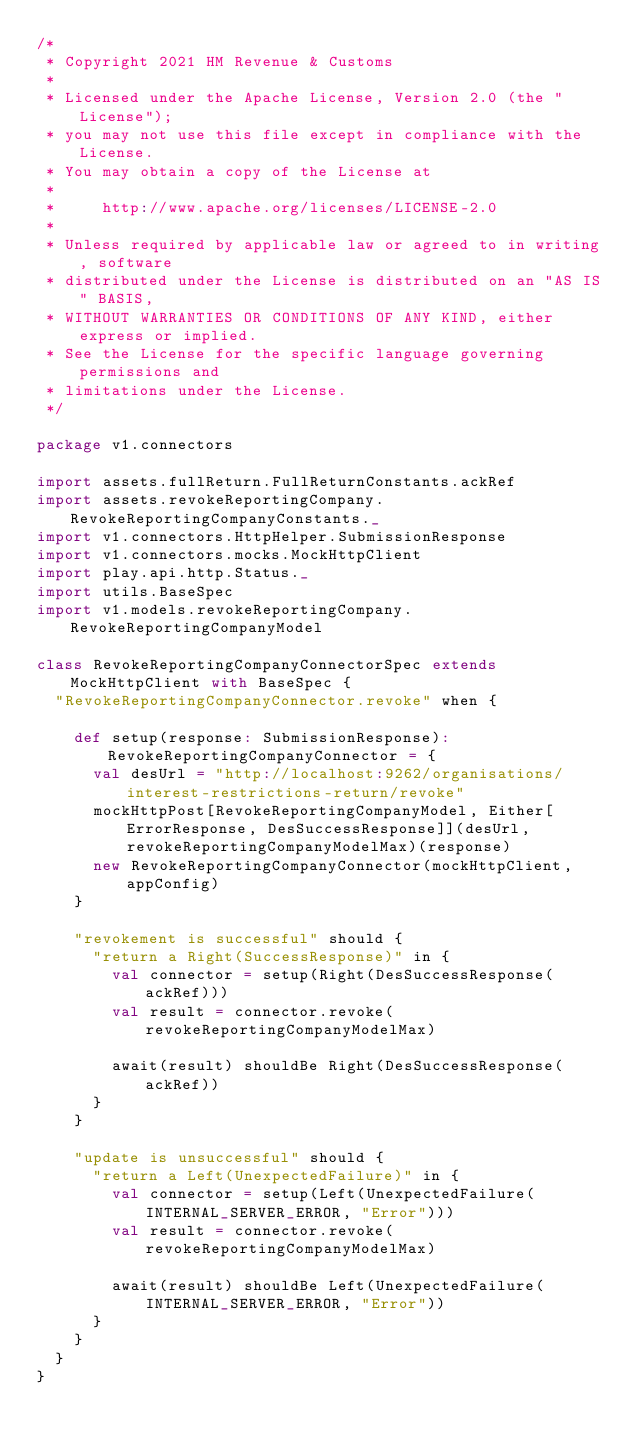Convert code to text. <code><loc_0><loc_0><loc_500><loc_500><_Scala_>/*
 * Copyright 2021 HM Revenue & Customs
 *
 * Licensed under the Apache License, Version 2.0 (the "License");
 * you may not use this file except in compliance with the License.
 * You may obtain a copy of the License at
 *
 *     http://www.apache.org/licenses/LICENSE-2.0
 *
 * Unless required by applicable law or agreed to in writing, software
 * distributed under the License is distributed on an "AS IS" BASIS,
 * WITHOUT WARRANTIES OR CONDITIONS OF ANY KIND, either express or implied.
 * See the License for the specific language governing permissions and
 * limitations under the License.
 */

package v1.connectors

import assets.fullReturn.FullReturnConstants.ackRef
import assets.revokeReportingCompany.RevokeReportingCompanyConstants._
import v1.connectors.HttpHelper.SubmissionResponse
import v1.connectors.mocks.MockHttpClient
import play.api.http.Status._
import utils.BaseSpec
import v1.models.revokeReportingCompany.RevokeReportingCompanyModel

class RevokeReportingCompanyConnectorSpec extends MockHttpClient with BaseSpec {
  "RevokeReportingCompanyConnector.revoke" when {

    def setup(response: SubmissionResponse): RevokeReportingCompanyConnector = {
      val desUrl = "http://localhost:9262/organisations/interest-restrictions-return/revoke"
      mockHttpPost[RevokeReportingCompanyModel, Either[ErrorResponse, DesSuccessResponse]](desUrl, revokeReportingCompanyModelMax)(response)
      new RevokeReportingCompanyConnector(mockHttpClient,appConfig)
    }

    "revokement is successful" should {
      "return a Right(SuccessResponse)" in {
        val connector = setup(Right(DesSuccessResponse(ackRef)))
        val result = connector.revoke(revokeReportingCompanyModelMax)

        await(result) shouldBe Right(DesSuccessResponse(ackRef))
      }
    }

    "update is unsuccessful" should {
      "return a Left(UnexpectedFailure)" in {
        val connector = setup(Left(UnexpectedFailure(INTERNAL_SERVER_ERROR, "Error")))
        val result = connector.revoke(revokeReportingCompanyModelMax)

        await(result) shouldBe Left(UnexpectedFailure(INTERNAL_SERVER_ERROR, "Error"))
      }
    }
  }
}
</code> 